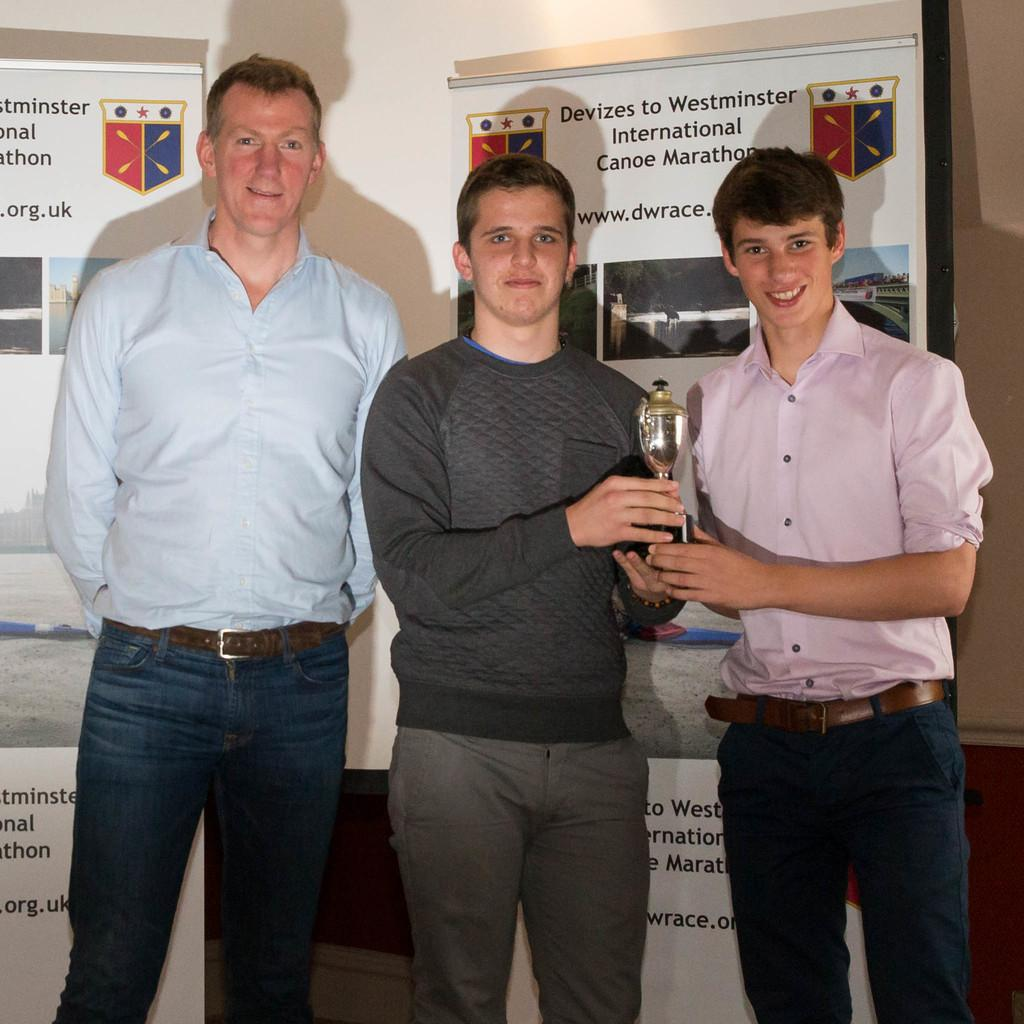What are the people in the image doing? The people in the image are standing and smiling. What are the people holding in their hands? The people are holding something in their hands, but the specific object is not mentioned in the facts. What can be seen in the background of the image? There is a wall and banners in the background of the image. What type of fog can be seen in the image? There is no fog present in the image. What industry is depicted in the image? The image does not depict any specific industry. 